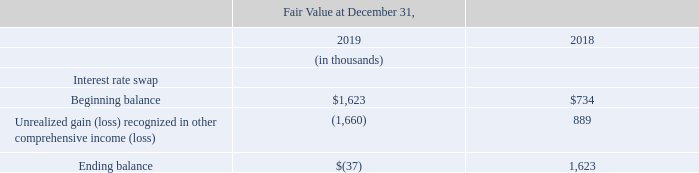The following table summarizes activity for the interest rate swap:
There were no transfers between Level 1, Level 2 or Level 3 fair value hierarchy categories of financial instruments in the years ended December 31, 2019 and 2018.
Financial Instruments Not Recorded at Fair Value on a Recurring Basis
Some of the Company’s financial instruments are not measured at fair value on a recurring basis but are recorded at amounts that approximate fair value due to their liquid or short-term nature. Such financial assets and financial liabilities include: cash and cash equivalents, restricted cash, net receivables, certain other assets, accounts payable, accrued price protection liability, accrued expenses, accrued compensation costs, and other current liabilities. The Company’s long-term debt is not recorded at fair value on a recurring basis, but is measured at fair value for disclosure purposes (Note8 ).
What were the transfers between Level 1, Level 2 and Level 3 in 2019 and 2018? There were no transfers between level 1, level 2 or level 3. How is the company's long-term debt recorded? Measured at fair value for disclosure purposes (note8 ). What was the Unrealized gain (loss) recognized in other comprehensive income (loss) in 2019 and 2018 respectively?
Answer scale should be: thousand. (1,660), 889. In which year was the beginning balance less than 1,000 thousands? Locate and analyze beginning balance in row 5
answer: 2018. What was the average Unrealized gain (loss) recognized in other comprehensive income (loss) for 2018 and 2019?
Answer scale should be: thousand. (-1,660 + 889) / 2
Answer: -385.5. What was the change in the ending balance from 2018 to 2019?
Answer scale should be: thousand. -37 - 1,623
Answer: -1660. 